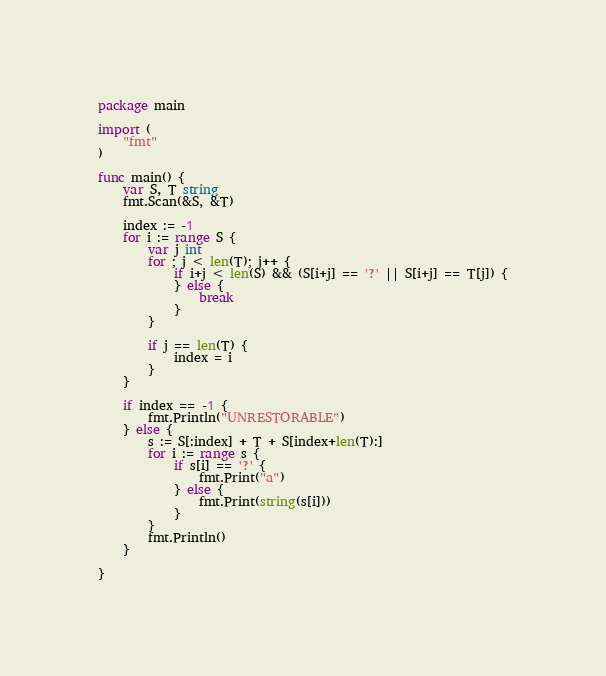<code> <loc_0><loc_0><loc_500><loc_500><_Go_>package main

import (
	"fmt"
)

func main() {
	var S, T string
	fmt.Scan(&S, &T)

	index := -1
	for i := range S {
		var j int
		for ; j < len(T); j++ {
			if i+j < len(S) && (S[i+j] == '?' || S[i+j] == T[j]) {
			} else {
				break
			}
		}

		if j == len(T) {
			index = i
		}
	}

	if index == -1 {
		fmt.Println("UNRESTORABLE")
	} else {
		s := S[:index] + T + S[index+len(T):]
		for i := range s {
			if s[i] == '?' {
				fmt.Print("a")
			} else {
				fmt.Print(string(s[i]))
			}
		}
		fmt.Println()
	}

}
</code> 